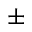<formula> <loc_0><loc_0><loc_500><loc_500>\pm</formula> 